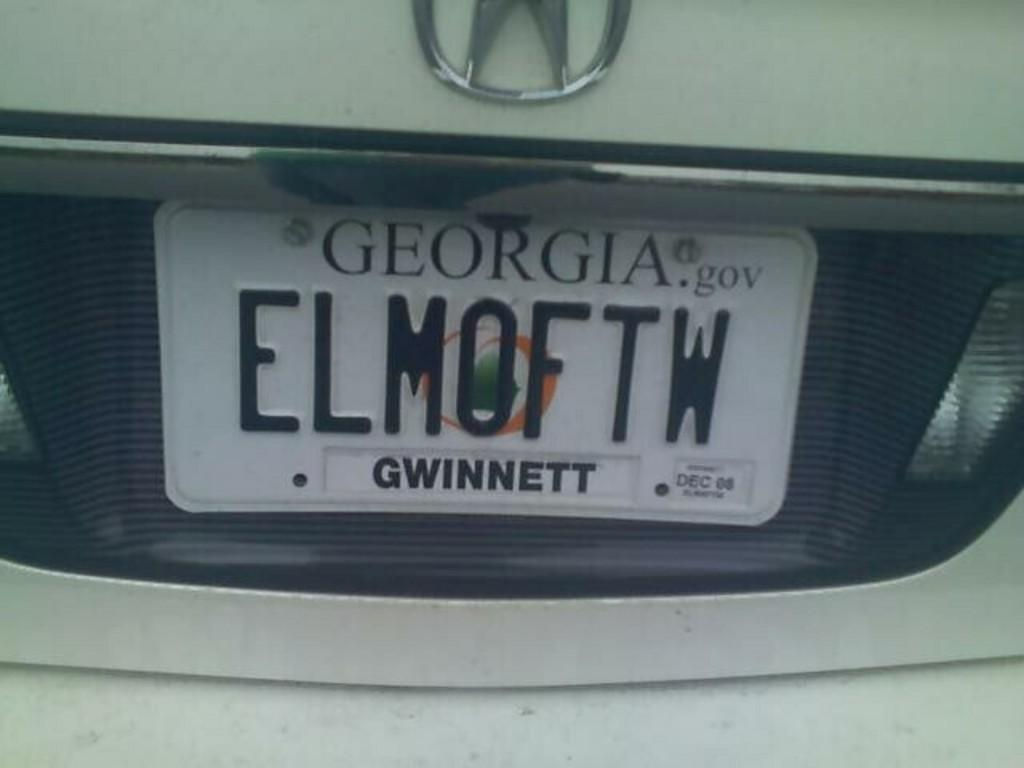<image>
Provide a brief description of the given image. the license plate ELMOFTW is from Gwinnett Georgia 